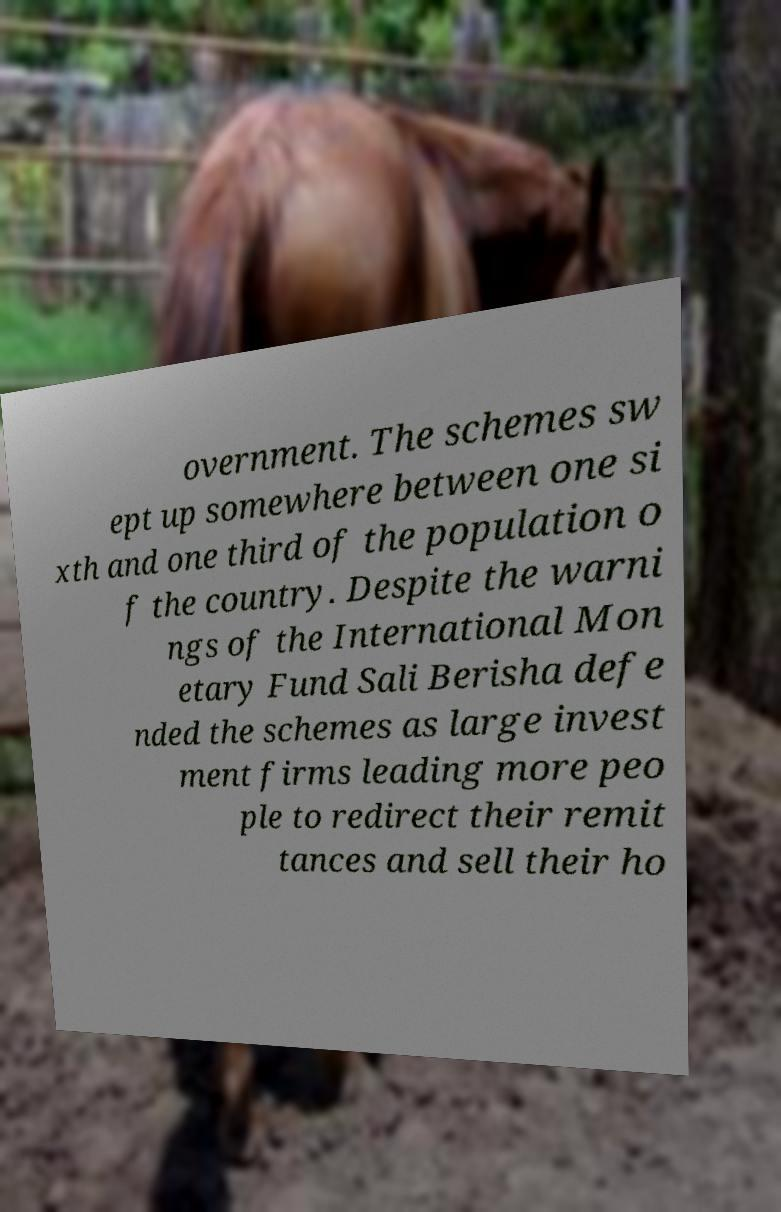There's text embedded in this image that I need extracted. Can you transcribe it verbatim? overnment. The schemes sw ept up somewhere between one si xth and one third of the population o f the country. Despite the warni ngs of the International Mon etary Fund Sali Berisha defe nded the schemes as large invest ment firms leading more peo ple to redirect their remit tances and sell their ho 